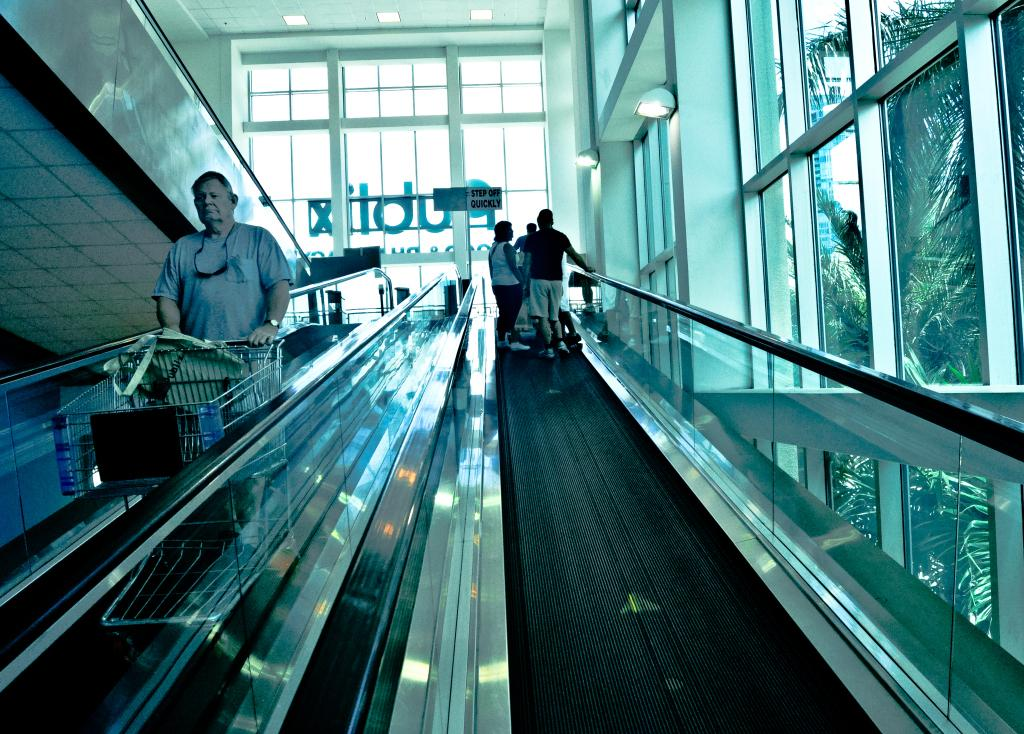<image>
Write a terse but informative summary of the picture. People go up the elevator in a Publix supermarket. 